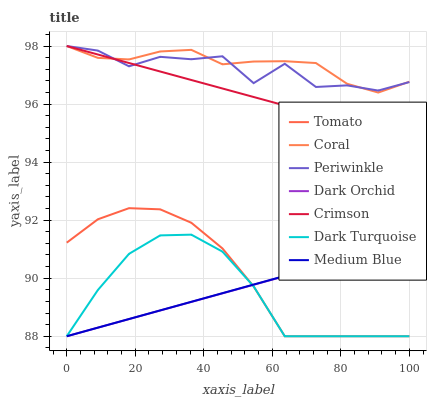Does Coral have the minimum area under the curve?
Answer yes or no. No. Does Dark Turquoise have the maximum area under the curve?
Answer yes or no. No. Is Dark Turquoise the smoothest?
Answer yes or no. No. Is Dark Turquoise the roughest?
Answer yes or no. No. Does Coral have the lowest value?
Answer yes or no. No. Does Dark Turquoise have the highest value?
Answer yes or no. No. Is Tomato less than Coral?
Answer yes or no. Yes. Is Periwinkle greater than Medium Blue?
Answer yes or no. Yes. Does Tomato intersect Coral?
Answer yes or no. No. 